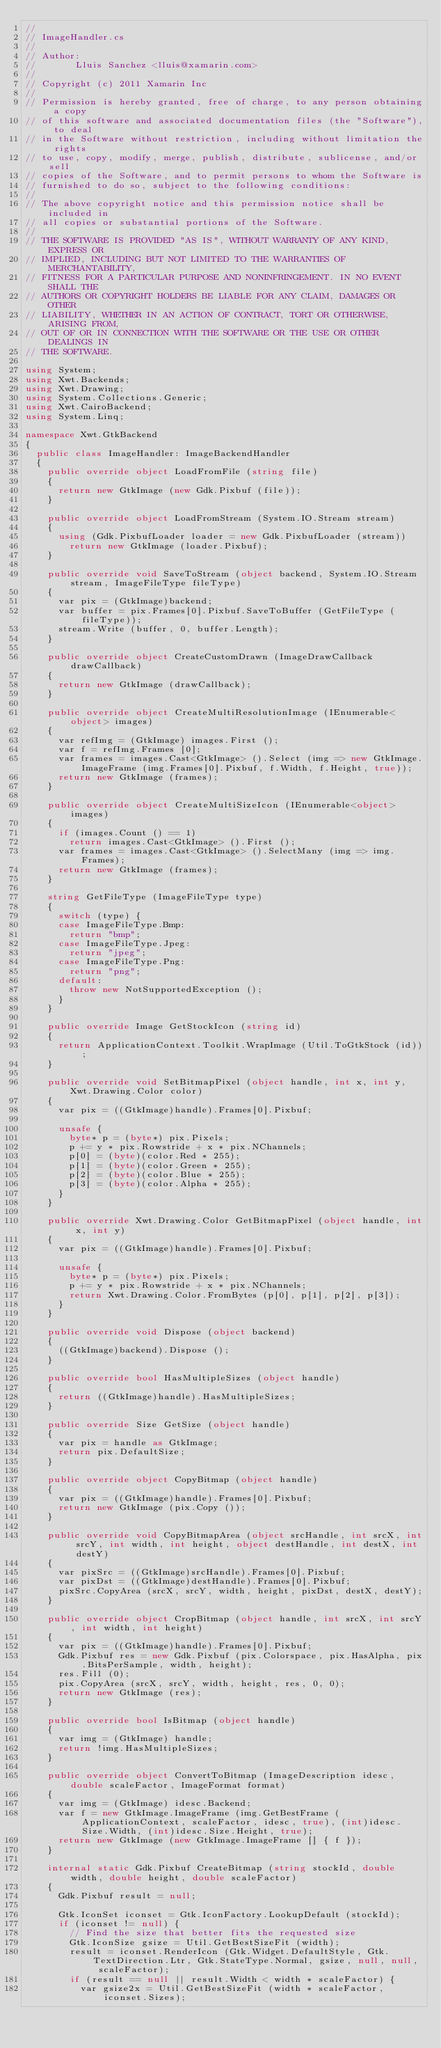<code> <loc_0><loc_0><loc_500><loc_500><_C#_>// 
// ImageHandler.cs
//  
// Author:
//       Lluis Sanchez <lluis@xamarin.com>
// 
// Copyright (c) 2011 Xamarin Inc
// 
// Permission is hereby granted, free of charge, to any person obtaining a copy
// of this software and associated documentation files (the "Software"), to deal
// in the Software without restriction, including without limitation the rights
// to use, copy, modify, merge, publish, distribute, sublicense, and/or sell
// copies of the Software, and to permit persons to whom the Software is
// furnished to do so, subject to the following conditions:
// 
// The above copyright notice and this permission notice shall be included in
// all copies or substantial portions of the Software.
// 
// THE SOFTWARE IS PROVIDED "AS IS", WITHOUT WARRANTY OF ANY KIND, EXPRESS OR
// IMPLIED, INCLUDING BUT NOT LIMITED TO THE WARRANTIES OF MERCHANTABILITY,
// FITNESS FOR A PARTICULAR PURPOSE AND NONINFRINGEMENT. IN NO EVENT SHALL THE
// AUTHORS OR COPYRIGHT HOLDERS BE LIABLE FOR ANY CLAIM, DAMAGES OR OTHER
// LIABILITY, WHETHER IN AN ACTION OF CONTRACT, TORT OR OTHERWISE, ARISING FROM,
// OUT OF OR IN CONNECTION WITH THE SOFTWARE OR THE USE OR OTHER DEALINGS IN
// THE SOFTWARE.

using System;
using Xwt.Backends;
using Xwt.Drawing;
using System.Collections.Generic;
using Xwt.CairoBackend;
using System.Linq;

namespace Xwt.GtkBackend
{
	public class ImageHandler: ImageBackendHandler
	{
		public override object LoadFromFile (string file)
		{
			return new GtkImage (new Gdk.Pixbuf (file));
		}

		public override object LoadFromStream (System.IO.Stream stream)
		{
			using (Gdk.PixbufLoader loader = new Gdk.PixbufLoader (stream))
				return new GtkImage (loader.Pixbuf);
		}

		public override void SaveToStream (object backend, System.IO.Stream stream, ImageFileType fileType)
		{
			var pix = (GtkImage)backend;
			var buffer = pix.Frames[0].Pixbuf.SaveToBuffer (GetFileType (fileType));
			stream.Write (buffer, 0, buffer.Length);
		}

		public override object CreateCustomDrawn (ImageDrawCallback drawCallback)
		{
			return new GtkImage (drawCallback);
		}

		public override object CreateMultiResolutionImage (IEnumerable<object> images)
		{
			var refImg = (GtkImage) images.First ();
			var f = refImg.Frames [0];
			var frames = images.Cast<GtkImage> ().Select (img => new GtkImage.ImageFrame (img.Frames[0].Pixbuf, f.Width, f.Height, true));
			return new GtkImage (frames);
		}

		public override object CreateMultiSizeIcon (IEnumerable<object> images)
		{
			if (images.Count () == 1)
				return images.Cast<GtkImage> ().First ();
			var frames = images.Cast<GtkImage> ().SelectMany (img => img.Frames);
			return new GtkImage (frames);
		}

		string GetFileType (ImageFileType type)
		{
			switch (type) {
			case ImageFileType.Bmp:
				return "bmp";
			case ImageFileType.Jpeg:
				return "jpeg";
			case ImageFileType.Png:
				return "png";
			default:
				throw new NotSupportedException ();
			}
		}

		public override Image GetStockIcon (string id)
		{
			return ApplicationContext.Toolkit.WrapImage (Util.ToGtkStock (id));
		}
		
		public override void SetBitmapPixel (object handle, int x, int y, Xwt.Drawing.Color color)
		{
			var pix = ((GtkImage)handle).Frames[0].Pixbuf;
			
			unsafe {
				byte* p = (byte*) pix.Pixels;
				p += y * pix.Rowstride + x * pix.NChannels;
				p[0] = (byte)(color.Red * 255);
				p[1] = (byte)(color.Green * 255);
				p[2] = (byte)(color.Blue * 255);
				p[3] = (byte)(color.Alpha * 255);
			}
		}
		
		public override Xwt.Drawing.Color GetBitmapPixel (object handle, int x, int y)
		{
			var pix = ((GtkImage)handle).Frames[0].Pixbuf;
			
			unsafe {
				byte* p = (byte*) pix.Pixels;
				p += y * pix.Rowstride + x * pix.NChannels;
				return Xwt.Drawing.Color.FromBytes (p[0], p[1], p[2], p[3]);
			}
		}
		
		public override void Dispose (object backend)
		{
			((GtkImage)backend).Dispose ();
		}

		public override bool HasMultipleSizes (object handle)
		{
			return ((GtkImage)handle).HasMultipleSizes;
		}

		public override Size GetSize (object handle)
		{
			var pix = handle as GtkImage;
			return pix.DefaultSize;
		}
		
		public override object CopyBitmap (object handle)
		{
			var pix = ((GtkImage)handle).Frames[0].Pixbuf;
			return new GtkImage (pix.Copy ());
		}
		
		public override void CopyBitmapArea (object srcHandle, int srcX, int srcY, int width, int height, object destHandle, int destX, int destY)
		{
			var pixSrc = ((GtkImage)srcHandle).Frames[0].Pixbuf;
			var pixDst = ((GtkImage)destHandle).Frames[0].Pixbuf;
			pixSrc.CopyArea (srcX, srcY, width, height, pixDst, destX, destY);
		}
		
		public override object CropBitmap (object handle, int srcX, int srcY, int width, int height)
		{
			var pix = ((GtkImage)handle).Frames[0].Pixbuf;
			Gdk.Pixbuf res = new Gdk.Pixbuf (pix.Colorspace, pix.HasAlpha, pix.BitsPerSample, width, height);
			res.Fill (0);
			pix.CopyArea (srcX, srcY, width, height, res, 0, 0);
			return new GtkImage (res);
		}
		
		public override bool IsBitmap (object handle)
		{
			var img = (GtkImage) handle;
			return !img.HasMultipleSizes;
		}

		public override object ConvertToBitmap (ImageDescription idesc, double scaleFactor, ImageFormat format)
		{
			var img = (GtkImage) idesc.Backend;
			var f = new GtkImage.ImageFrame (img.GetBestFrame (ApplicationContext, scaleFactor, idesc, true), (int)idesc.Size.Width, (int)idesc.Size.Height, true);
			return new GtkImage (new GtkImage.ImageFrame [] { f });
		}

		internal static Gdk.Pixbuf CreateBitmap (string stockId, double width, double height, double scaleFactor)
		{
			Gdk.Pixbuf result = null;

			Gtk.IconSet iconset = Gtk.IconFactory.LookupDefault (stockId);
			if (iconset != null) {
				// Find the size that better fits the requested size
				Gtk.IconSize gsize = Util.GetBestSizeFit (width);
				result = iconset.RenderIcon (Gtk.Widget.DefaultStyle, Gtk.TextDirection.Ltr, Gtk.StateType.Normal, gsize, null, null, scaleFactor);
				if (result == null || result.Width < width * scaleFactor) {
					var gsize2x = Util.GetBestSizeFit (width * scaleFactor, iconset.Sizes);</code> 